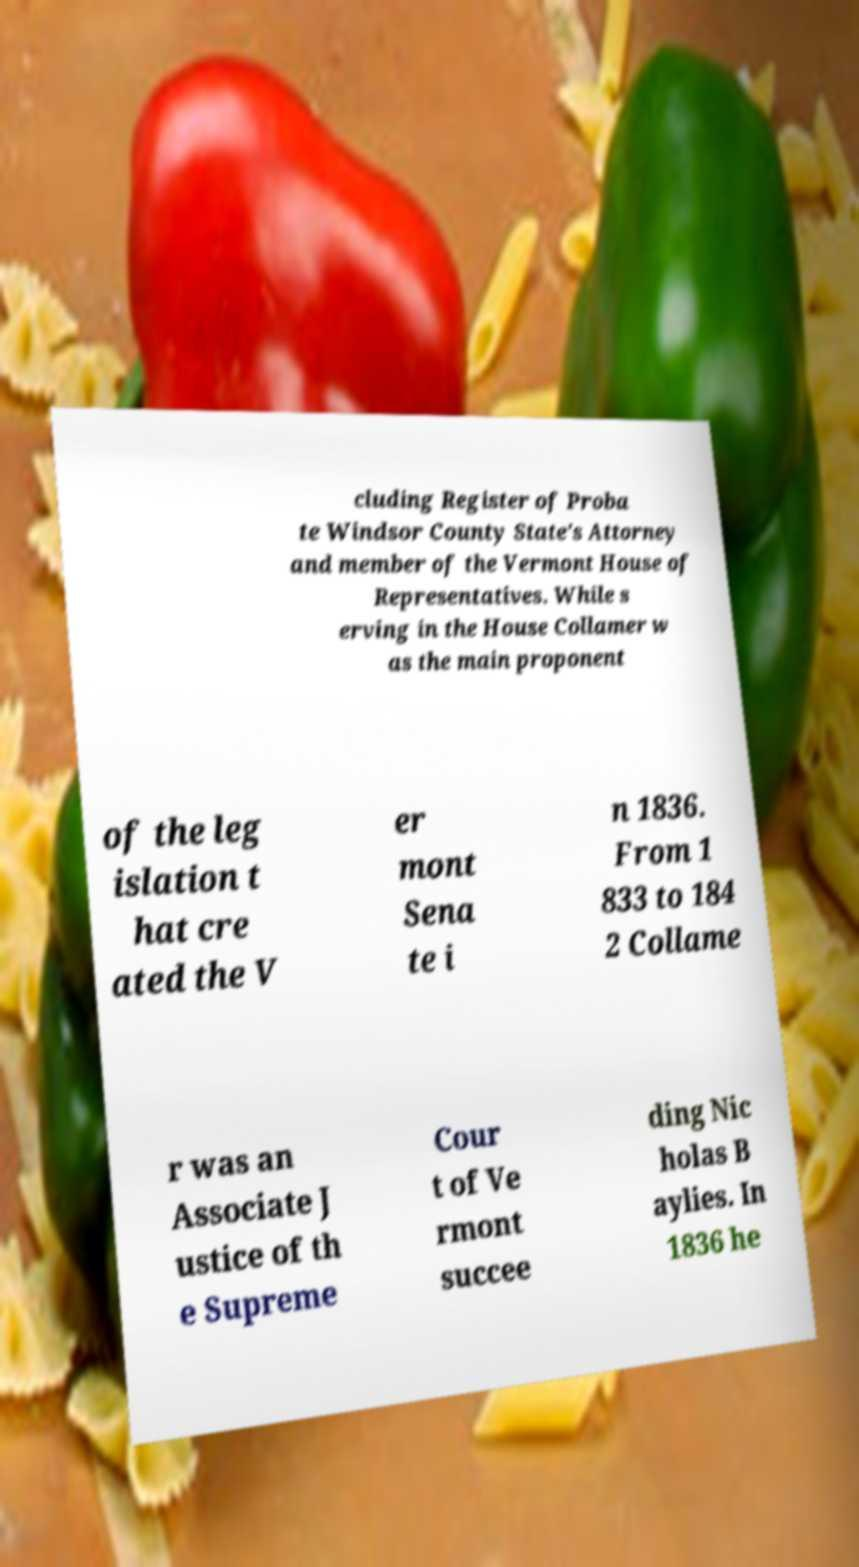Please identify and transcribe the text found in this image. cluding Register of Proba te Windsor County State's Attorney and member of the Vermont House of Representatives. While s erving in the House Collamer w as the main proponent of the leg islation t hat cre ated the V er mont Sena te i n 1836. From 1 833 to 184 2 Collame r was an Associate J ustice of th e Supreme Cour t of Ve rmont succee ding Nic holas B aylies. In 1836 he 